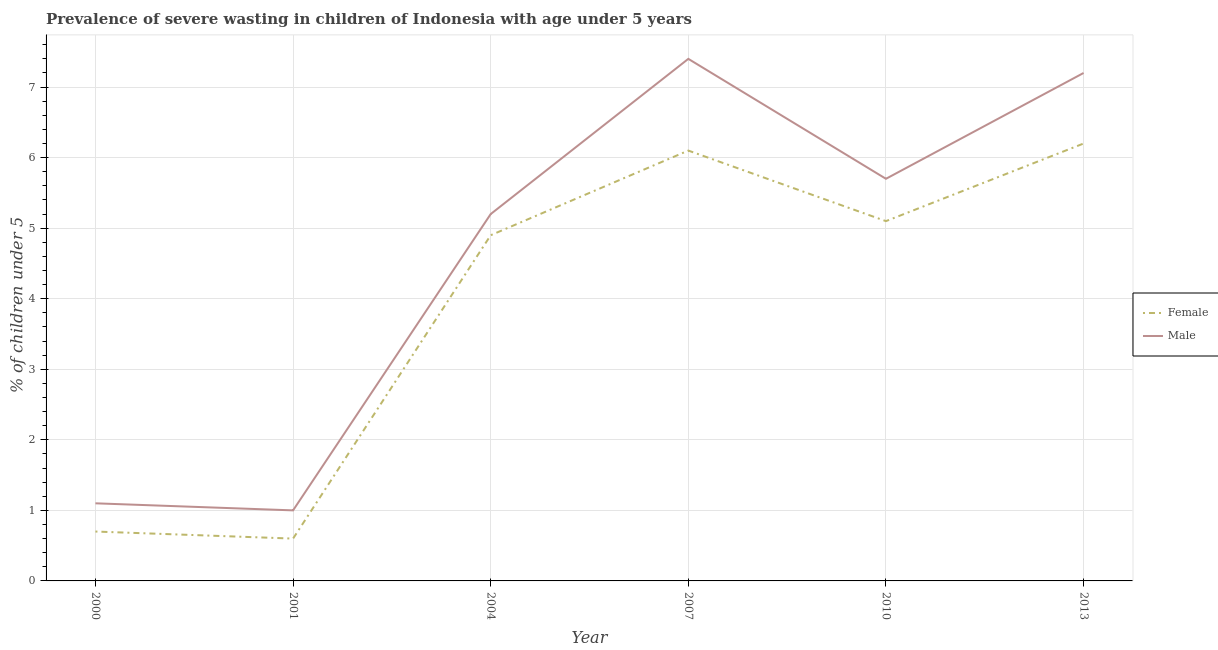How many different coloured lines are there?
Your answer should be compact. 2. What is the percentage of undernourished male children in 2004?
Ensure brevity in your answer.  5.2. Across all years, what is the maximum percentage of undernourished male children?
Your answer should be compact. 7.4. Across all years, what is the minimum percentage of undernourished male children?
Ensure brevity in your answer.  1. In which year was the percentage of undernourished female children maximum?
Provide a succinct answer. 2013. In which year was the percentage of undernourished male children minimum?
Make the answer very short. 2001. What is the total percentage of undernourished male children in the graph?
Ensure brevity in your answer.  27.6. What is the difference between the percentage of undernourished female children in 2007 and that in 2010?
Your answer should be very brief. 1. What is the difference between the percentage of undernourished female children in 2004 and the percentage of undernourished male children in 2007?
Keep it short and to the point. -2.5. What is the average percentage of undernourished male children per year?
Your response must be concise. 4.6. In the year 2004, what is the difference between the percentage of undernourished male children and percentage of undernourished female children?
Offer a terse response. 0.3. What is the ratio of the percentage of undernourished female children in 2000 to that in 2004?
Ensure brevity in your answer.  0.14. Is the percentage of undernourished male children in 2001 less than that in 2013?
Make the answer very short. Yes. Is the difference between the percentage of undernourished male children in 2000 and 2004 greater than the difference between the percentage of undernourished female children in 2000 and 2004?
Give a very brief answer. Yes. What is the difference between the highest and the second highest percentage of undernourished female children?
Give a very brief answer. 0.1. What is the difference between the highest and the lowest percentage of undernourished male children?
Give a very brief answer. 6.4. In how many years, is the percentage of undernourished female children greater than the average percentage of undernourished female children taken over all years?
Your answer should be compact. 4. Is the sum of the percentage of undernourished male children in 2004 and 2007 greater than the maximum percentage of undernourished female children across all years?
Keep it short and to the point. Yes. Does the percentage of undernourished female children monotonically increase over the years?
Ensure brevity in your answer.  No. Is the percentage of undernourished male children strictly less than the percentage of undernourished female children over the years?
Provide a succinct answer. No. How many years are there in the graph?
Provide a succinct answer. 6. Does the graph contain any zero values?
Make the answer very short. No. Where does the legend appear in the graph?
Your answer should be compact. Center right. How are the legend labels stacked?
Offer a very short reply. Vertical. What is the title of the graph?
Offer a terse response. Prevalence of severe wasting in children of Indonesia with age under 5 years. What is the label or title of the X-axis?
Provide a short and direct response. Year. What is the label or title of the Y-axis?
Keep it short and to the point.  % of children under 5. What is the  % of children under 5 in Female in 2000?
Provide a short and direct response. 0.7. What is the  % of children under 5 in Male in 2000?
Offer a very short reply. 1.1. What is the  % of children under 5 of Female in 2001?
Give a very brief answer. 0.6. What is the  % of children under 5 of Male in 2001?
Give a very brief answer. 1. What is the  % of children under 5 of Female in 2004?
Your answer should be compact. 4.9. What is the  % of children under 5 of Male in 2004?
Keep it short and to the point. 5.2. What is the  % of children under 5 of Female in 2007?
Ensure brevity in your answer.  6.1. What is the  % of children under 5 of Male in 2007?
Give a very brief answer. 7.4. What is the  % of children under 5 of Female in 2010?
Provide a short and direct response. 5.1. What is the  % of children under 5 in Male in 2010?
Provide a succinct answer. 5.7. What is the  % of children under 5 of Female in 2013?
Your answer should be compact. 6.2. What is the  % of children under 5 in Male in 2013?
Keep it short and to the point. 7.2. Across all years, what is the maximum  % of children under 5 of Female?
Provide a succinct answer. 6.2. Across all years, what is the maximum  % of children under 5 in Male?
Offer a very short reply. 7.4. Across all years, what is the minimum  % of children under 5 of Female?
Give a very brief answer. 0.6. Across all years, what is the minimum  % of children under 5 in Male?
Your answer should be compact. 1. What is the total  % of children under 5 of Female in the graph?
Give a very brief answer. 23.6. What is the total  % of children under 5 of Male in the graph?
Your answer should be very brief. 27.6. What is the difference between the  % of children under 5 in Female in 2000 and that in 2001?
Your response must be concise. 0.1. What is the difference between the  % of children under 5 in Male in 2000 and that in 2001?
Provide a succinct answer. 0.1. What is the difference between the  % of children under 5 in Male in 2000 and that in 2004?
Make the answer very short. -4.1. What is the difference between the  % of children under 5 in Female in 2001 and that in 2004?
Provide a succinct answer. -4.3. What is the difference between the  % of children under 5 in Male in 2001 and that in 2004?
Give a very brief answer. -4.2. What is the difference between the  % of children under 5 in Male in 2001 and that in 2007?
Offer a terse response. -6.4. What is the difference between the  % of children under 5 of Female in 2001 and that in 2010?
Ensure brevity in your answer.  -4.5. What is the difference between the  % of children under 5 in Male in 2001 and that in 2013?
Offer a terse response. -6.2. What is the difference between the  % of children under 5 in Female in 2004 and that in 2013?
Give a very brief answer. -1.3. What is the difference between the  % of children under 5 of Female in 2007 and that in 2010?
Your answer should be very brief. 1. What is the difference between the  % of children under 5 of Male in 2007 and that in 2010?
Keep it short and to the point. 1.7. What is the difference between the  % of children under 5 in Female in 2007 and that in 2013?
Your answer should be compact. -0.1. What is the difference between the  % of children under 5 in Male in 2010 and that in 2013?
Provide a short and direct response. -1.5. What is the difference between the  % of children under 5 in Female in 2000 and the  % of children under 5 in Male in 2001?
Make the answer very short. -0.3. What is the difference between the  % of children under 5 in Female in 2000 and the  % of children under 5 in Male in 2007?
Provide a succinct answer. -6.7. What is the difference between the  % of children under 5 of Female in 2000 and the  % of children under 5 of Male in 2010?
Offer a terse response. -5. What is the difference between the  % of children under 5 in Female in 2000 and the  % of children under 5 in Male in 2013?
Keep it short and to the point. -6.5. What is the difference between the  % of children under 5 in Female in 2001 and the  % of children under 5 in Male in 2004?
Offer a terse response. -4.6. What is the difference between the  % of children under 5 in Female in 2001 and the  % of children under 5 in Male in 2013?
Offer a very short reply. -6.6. What is the difference between the  % of children under 5 in Female in 2004 and the  % of children under 5 in Male in 2007?
Offer a terse response. -2.5. What is the difference between the  % of children under 5 of Female in 2004 and the  % of children under 5 of Male in 2010?
Offer a terse response. -0.8. What is the difference between the  % of children under 5 in Female in 2004 and the  % of children under 5 in Male in 2013?
Provide a short and direct response. -2.3. What is the difference between the  % of children under 5 in Female in 2007 and the  % of children under 5 in Male in 2010?
Offer a very short reply. 0.4. What is the average  % of children under 5 in Female per year?
Offer a very short reply. 3.93. What is the average  % of children under 5 of Male per year?
Give a very brief answer. 4.6. In the year 2007, what is the difference between the  % of children under 5 in Female and  % of children under 5 in Male?
Offer a very short reply. -1.3. What is the ratio of the  % of children under 5 of Female in 2000 to that in 2004?
Give a very brief answer. 0.14. What is the ratio of the  % of children under 5 in Male in 2000 to that in 2004?
Offer a terse response. 0.21. What is the ratio of the  % of children under 5 in Female in 2000 to that in 2007?
Your answer should be compact. 0.11. What is the ratio of the  % of children under 5 in Male in 2000 to that in 2007?
Give a very brief answer. 0.15. What is the ratio of the  % of children under 5 of Female in 2000 to that in 2010?
Provide a short and direct response. 0.14. What is the ratio of the  % of children under 5 in Male in 2000 to that in 2010?
Offer a very short reply. 0.19. What is the ratio of the  % of children under 5 in Female in 2000 to that in 2013?
Your answer should be compact. 0.11. What is the ratio of the  % of children under 5 in Male in 2000 to that in 2013?
Your answer should be very brief. 0.15. What is the ratio of the  % of children under 5 of Female in 2001 to that in 2004?
Make the answer very short. 0.12. What is the ratio of the  % of children under 5 in Male in 2001 to that in 2004?
Keep it short and to the point. 0.19. What is the ratio of the  % of children under 5 of Female in 2001 to that in 2007?
Your response must be concise. 0.1. What is the ratio of the  % of children under 5 of Male in 2001 to that in 2007?
Provide a succinct answer. 0.14. What is the ratio of the  % of children under 5 in Female in 2001 to that in 2010?
Your response must be concise. 0.12. What is the ratio of the  % of children under 5 of Male in 2001 to that in 2010?
Offer a terse response. 0.18. What is the ratio of the  % of children under 5 of Female in 2001 to that in 2013?
Provide a short and direct response. 0.1. What is the ratio of the  % of children under 5 of Male in 2001 to that in 2013?
Provide a short and direct response. 0.14. What is the ratio of the  % of children under 5 in Female in 2004 to that in 2007?
Provide a succinct answer. 0.8. What is the ratio of the  % of children under 5 in Male in 2004 to that in 2007?
Your answer should be compact. 0.7. What is the ratio of the  % of children under 5 of Female in 2004 to that in 2010?
Provide a succinct answer. 0.96. What is the ratio of the  % of children under 5 of Male in 2004 to that in 2010?
Offer a terse response. 0.91. What is the ratio of the  % of children under 5 of Female in 2004 to that in 2013?
Your answer should be compact. 0.79. What is the ratio of the  % of children under 5 of Male in 2004 to that in 2013?
Ensure brevity in your answer.  0.72. What is the ratio of the  % of children under 5 of Female in 2007 to that in 2010?
Keep it short and to the point. 1.2. What is the ratio of the  % of children under 5 in Male in 2007 to that in 2010?
Offer a very short reply. 1.3. What is the ratio of the  % of children under 5 in Female in 2007 to that in 2013?
Make the answer very short. 0.98. What is the ratio of the  % of children under 5 in Male in 2007 to that in 2013?
Make the answer very short. 1.03. What is the ratio of the  % of children under 5 of Female in 2010 to that in 2013?
Offer a terse response. 0.82. What is the ratio of the  % of children under 5 of Male in 2010 to that in 2013?
Provide a succinct answer. 0.79. What is the difference between the highest and the second highest  % of children under 5 of Female?
Make the answer very short. 0.1. What is the difference between the highest and the lowest  % of children under 5 in Male?
Make the answer very short. 6.4. 